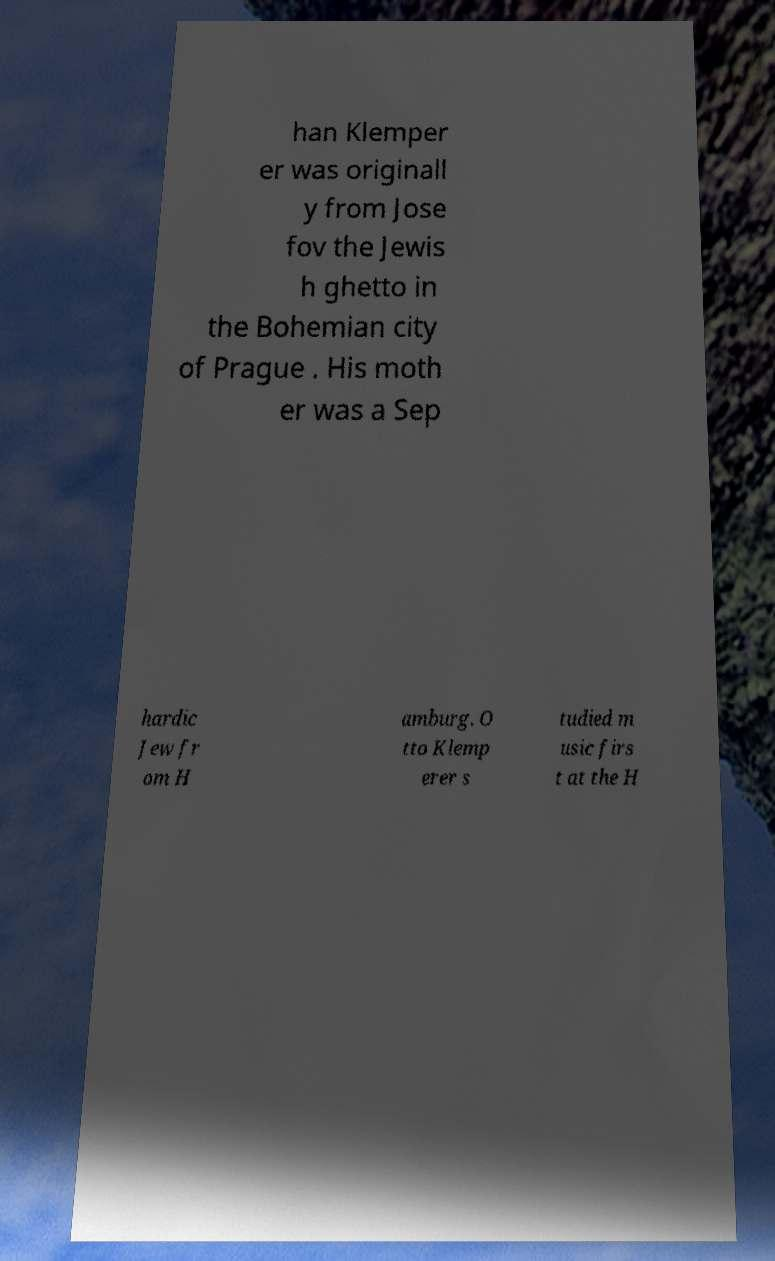Could you assist in decoding the text presented in this image and type it out clearly? han Klemper er was originall y from Jose fov the Jewis h ghetto in the Bohemian city of Prague . His moth er was a Sep hardic Jew fr om H amburg. O tto Klemp erer s tudied m usic firs t at the H 